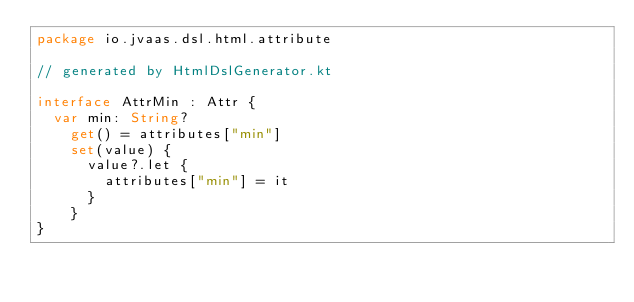<code> <loc_0><loc_0><loc_500><loc_500><_Kotlin_>package io.jvaas.dsl.html.attribute

// generated by HtmlDslGenerator.kt

interface AttrMin : Attr {
	var min: String?
		get() = attributes["min"]
		set(value) {
			value?.let {
				attributes["min"] = it
			}
		}
}	
</code> 